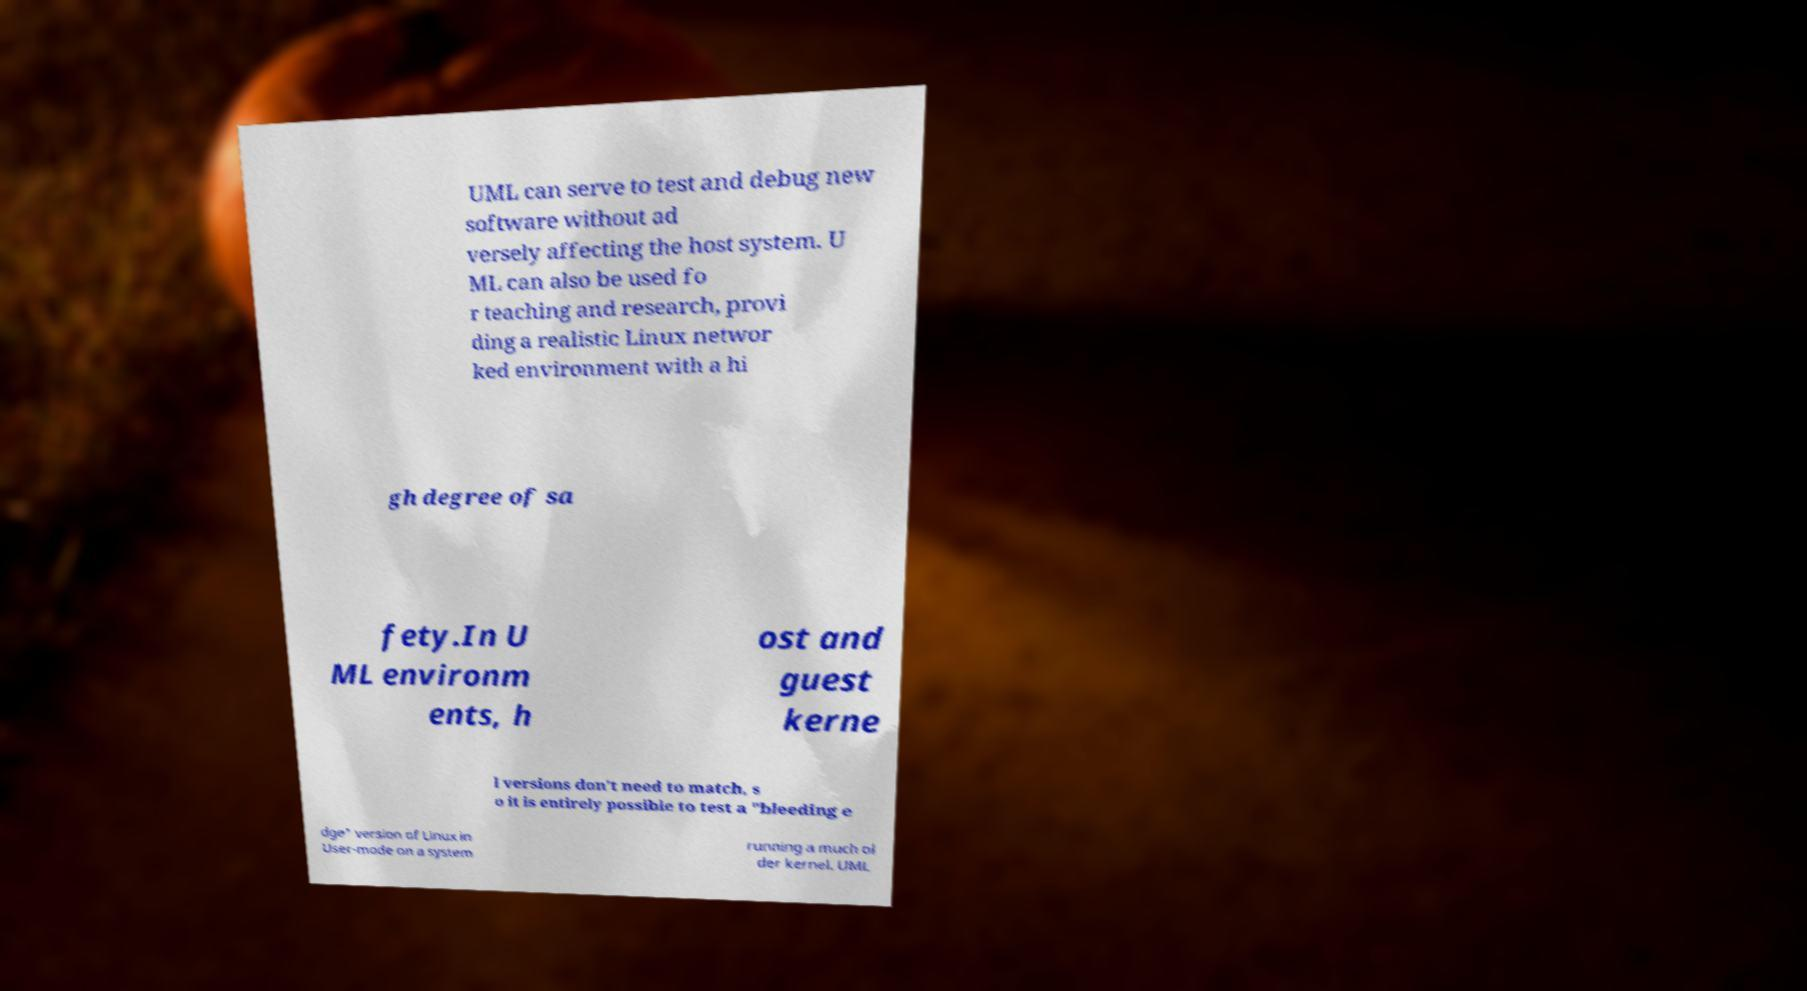Could you extract and type out the text from this image? UML can serve to test and debug new software without ad versely affecting the host system. U ML can also be used fo r teaching and research, provi ding a realistic Linux networ ked environment with a hi gh degree of sa fety.In U ML environm ents, h ost and guest kerne l versions don't need to match, s o it is entirely possible to test a "bleeding e dge" version of Linux in User-mode on a system running a much ol der kernel. UML 